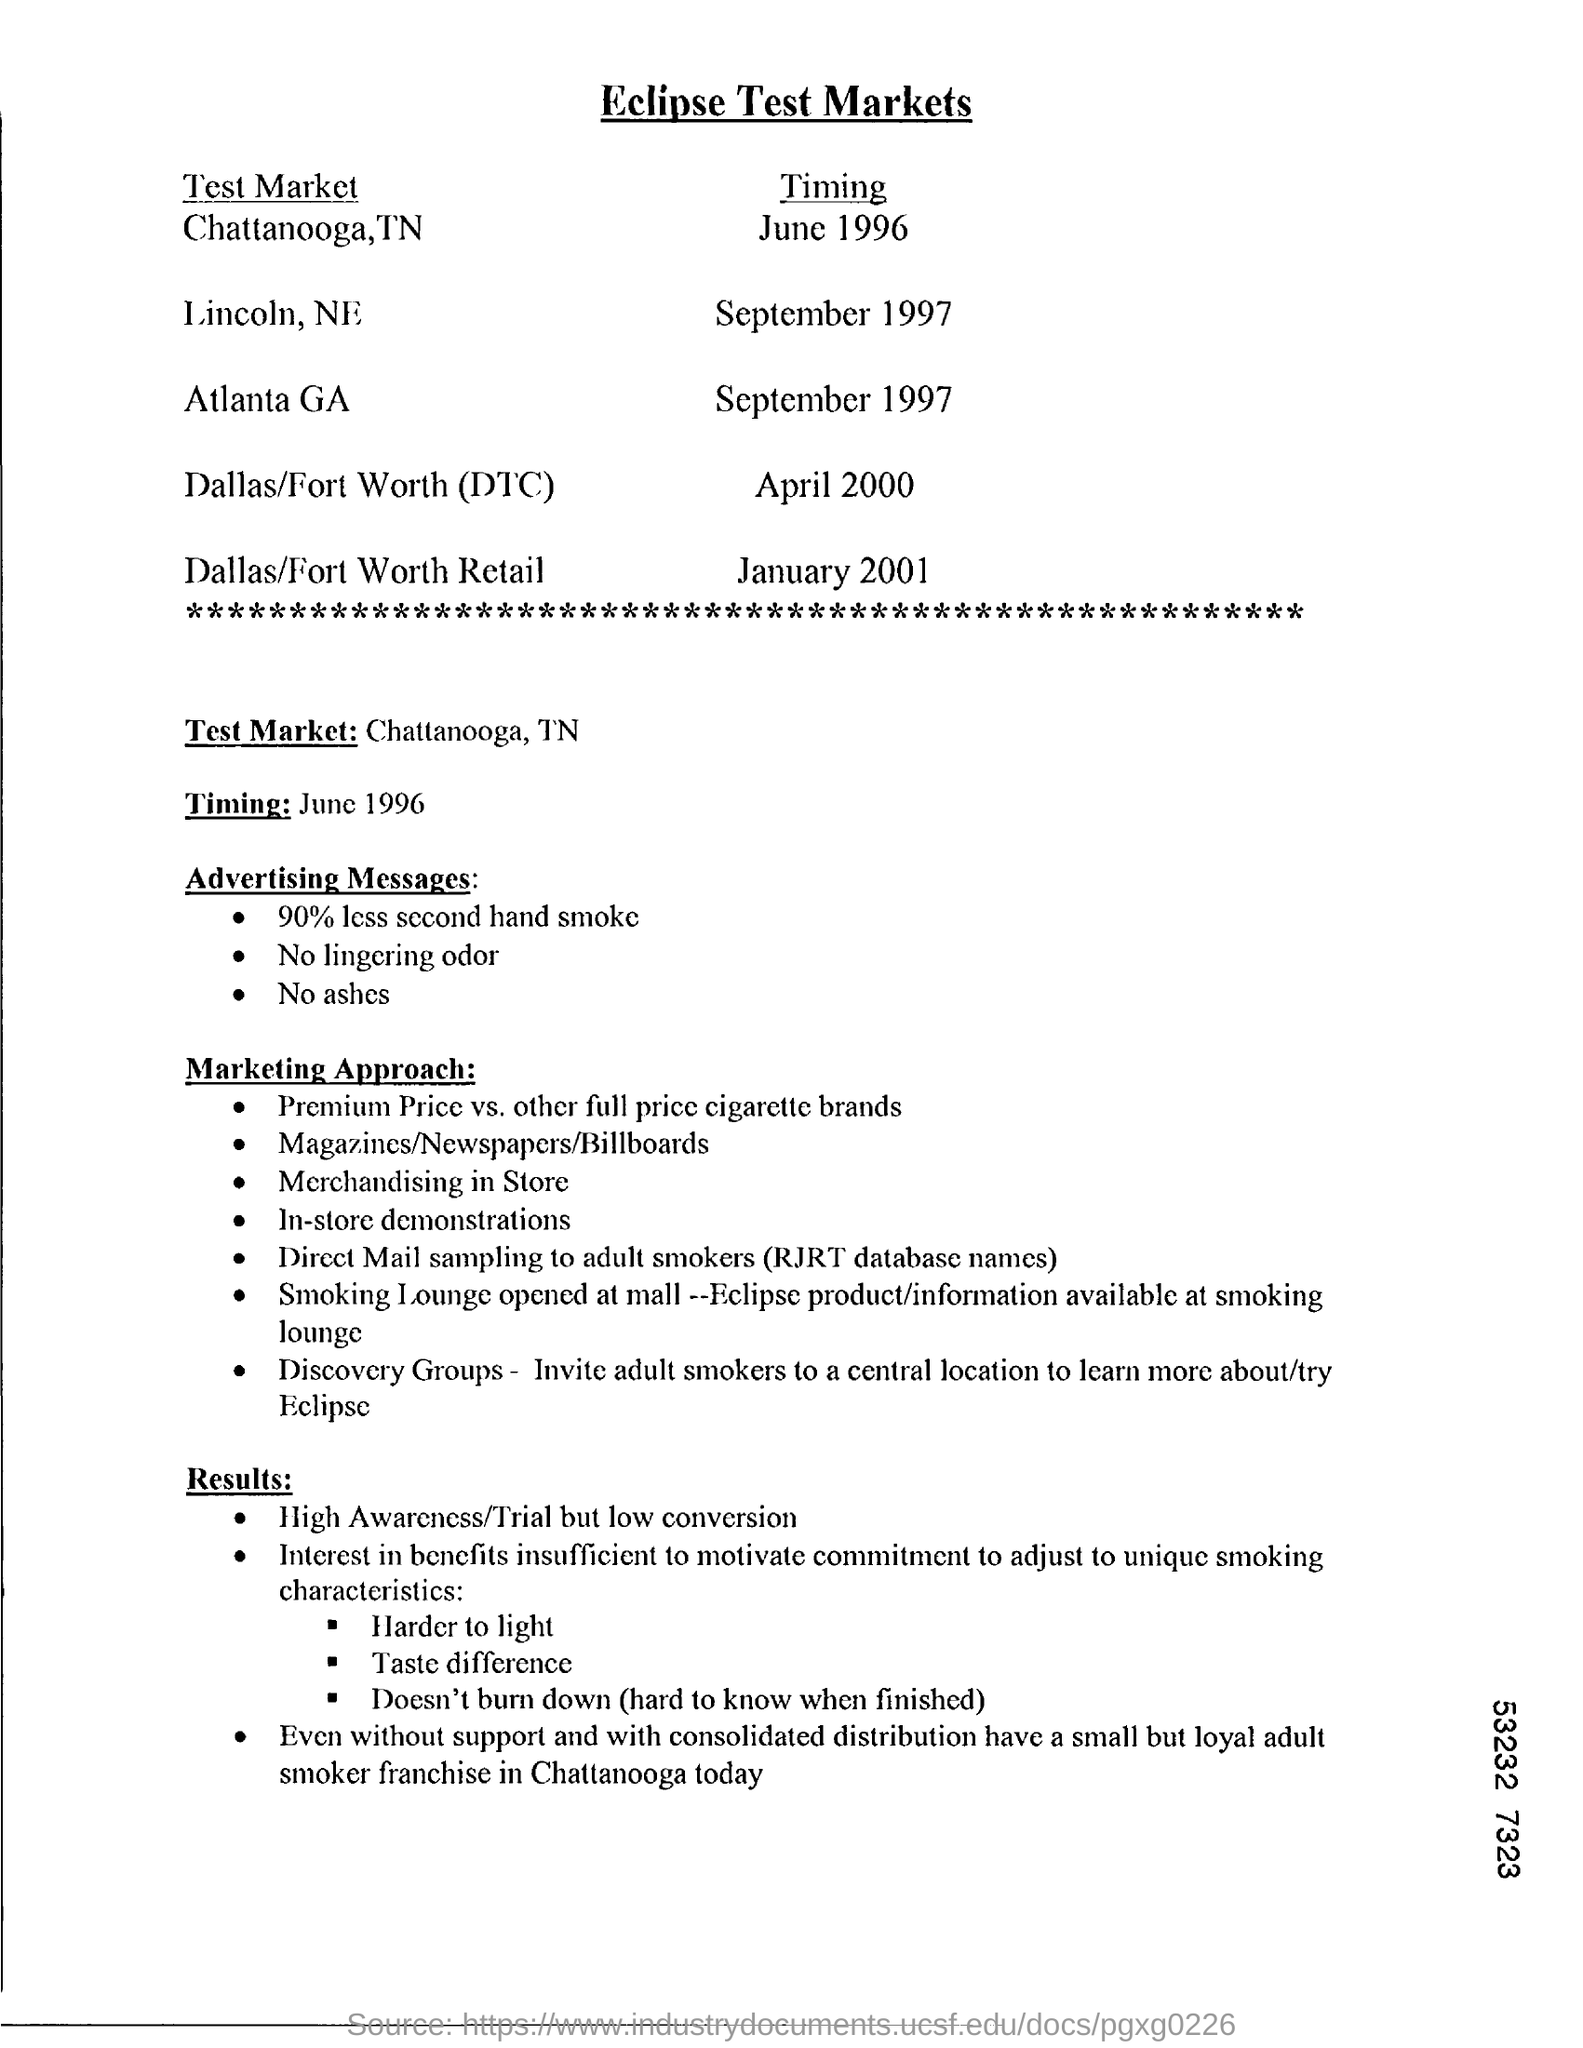When is the Timing for Atlanta GA?
Your answer should be compact. September 1997. When is the Timing for Dallas/Fort Worth (DTC)?
Your answer should be very brief. April 2000. 